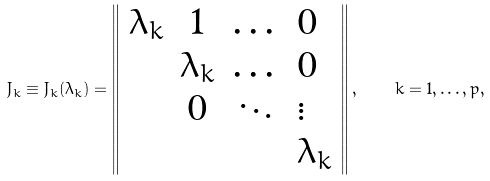<formula> <loc_0><loc_0><loc_500><loc_500>J _ { k } \equiv J _ { k } ( \lambda _ { k } ) = \left \| \begin{array} { c c c l } \lambda _ { k } & 1 & \dots & 0 \\ & \lambda _ { k } & \dots & 0 \\ & 0 & \ddots & \vdots \\ & & & \lambda _ { k } \end{array} \right \| , \quad k = 1 , \dots , p ,</formula> 